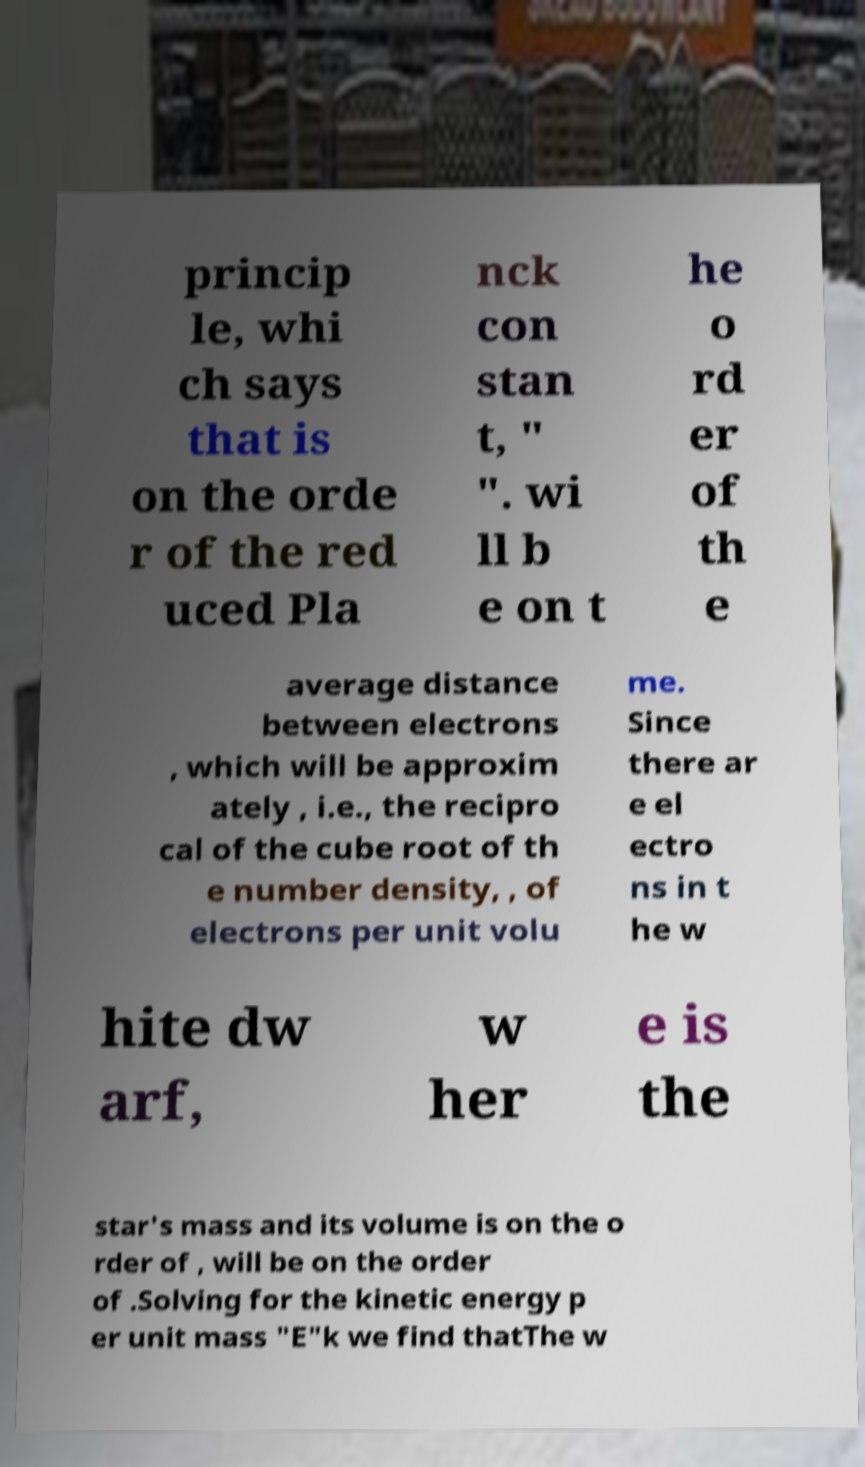Can you read and provide the text displayed in the image?This photo seems to have some interesting text. Can you extract and type it out for me? princip le, whi ch says that is on the orde r of the red uced Pla nck con stan t, " ". wi ll b e on t he o rd er of th e average distance between electrons , which will be approxim ately , i.e., the recipro cal of the cube root of th e number density, , of electrons per unit volu me. Since there ar e el ectro ns in t he w hite dw arf, w her e is the star's mass and its volume is on the o rder of , will be on the order of .Solving for the kinetic energy p er unit mass "E"k we find thatThe w 